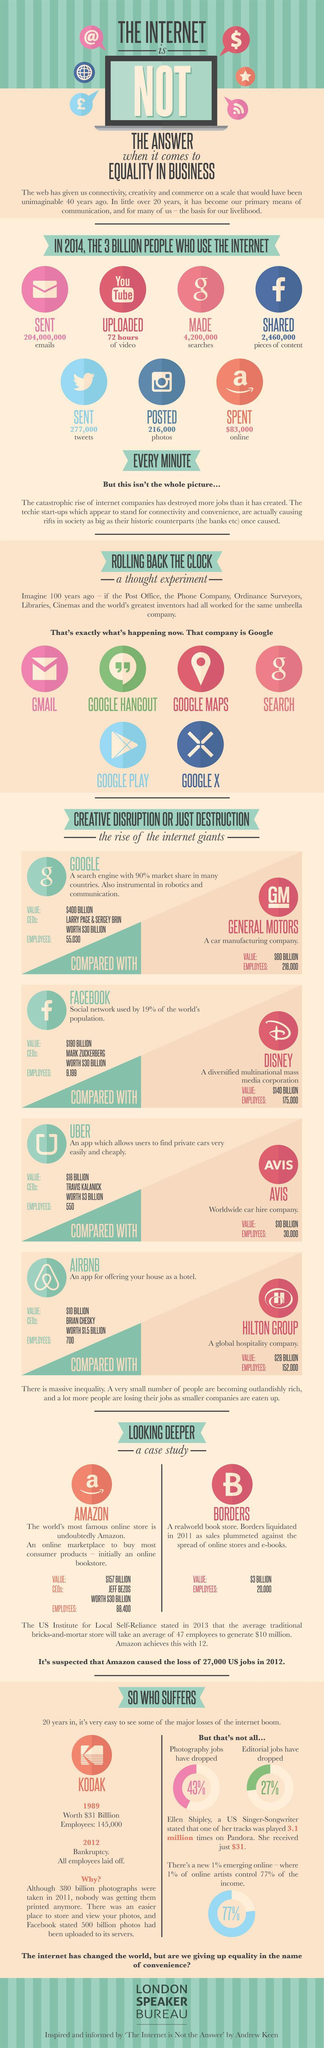Which app was used to share photos on the internet, Twitter, Instagram, or Facebook?
Answer the question with a short phrase. Instagram How many services are provided by Google? 6 How many pieces of content was shared on Facebook every minute, 204,000,000, 4,200,000, or 2,460,000? 2,460,000 